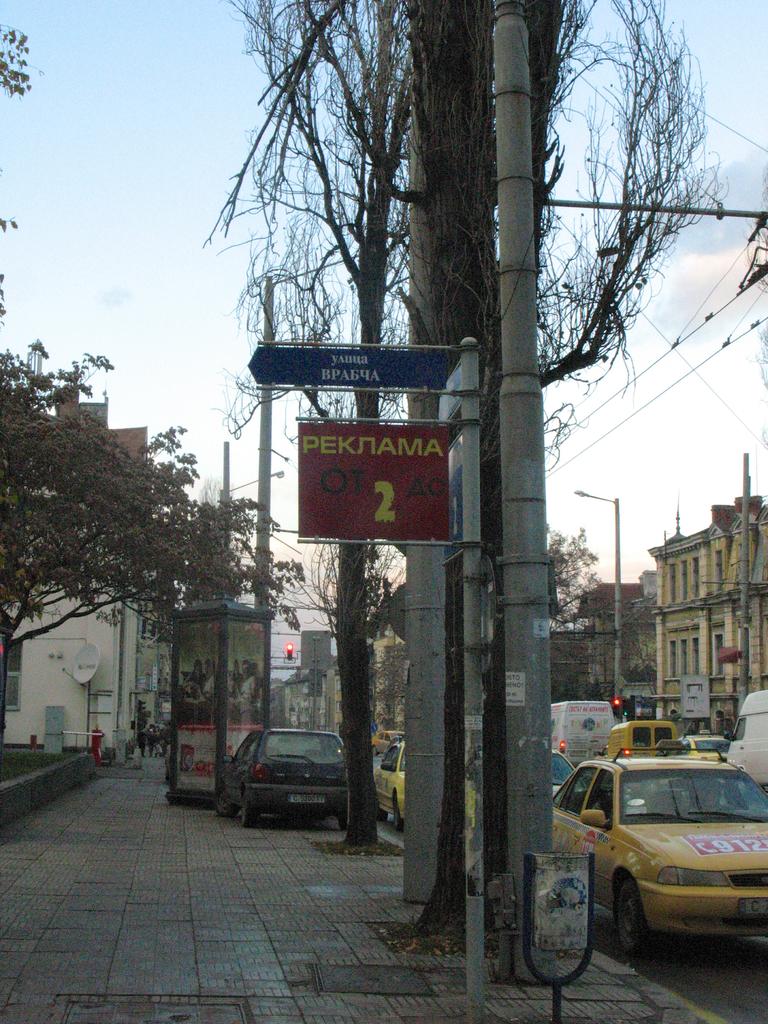What number is on the sign?
Make the answer very short. 2. What white numbers can be seen on the taxi?
Your response must be concise. 912. 